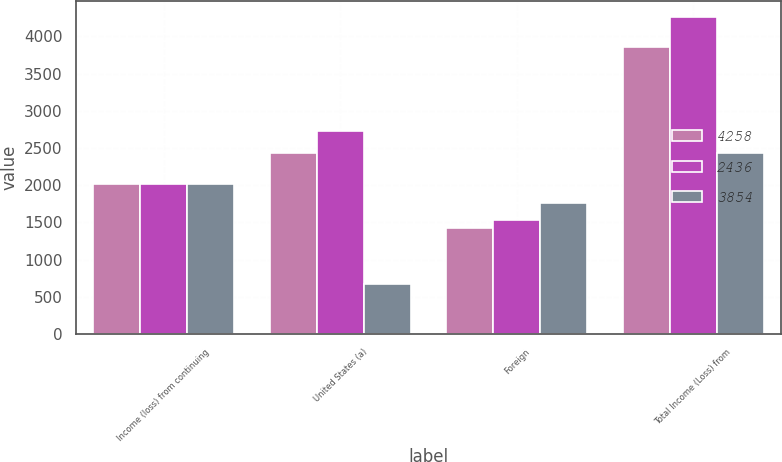<chart> <loc_0><loc_0><loc_500><loc_500><stacked_bar_chart><ecel><fcel>Income (loss) from continuing<fcel>United States (a)<fcel>Foreign<fcel>Total Income (Loss) from<nl><fcel>4258<fcel>2016<fcel>2431<fcel>1423<fcel>3854<nl><fcel>2436<fcel>2015<fcel>2728<fcel>1530<fcel>4258<nl><fcel>3854<fcel>2014<fcel>676<fcel>1760<fcel>2436<nl></chart> 